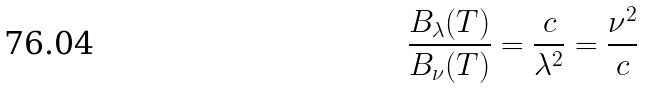<formula> <loc_0><loc_0><loc_500><loc_500>\frac { B _ { \lambda } ( T ) } { B _ { \nu } ( T ) } = \frac { c } { \lambda ^ { 2 } } = \frac { \nu ^ { 2 } } { c }</formula> 